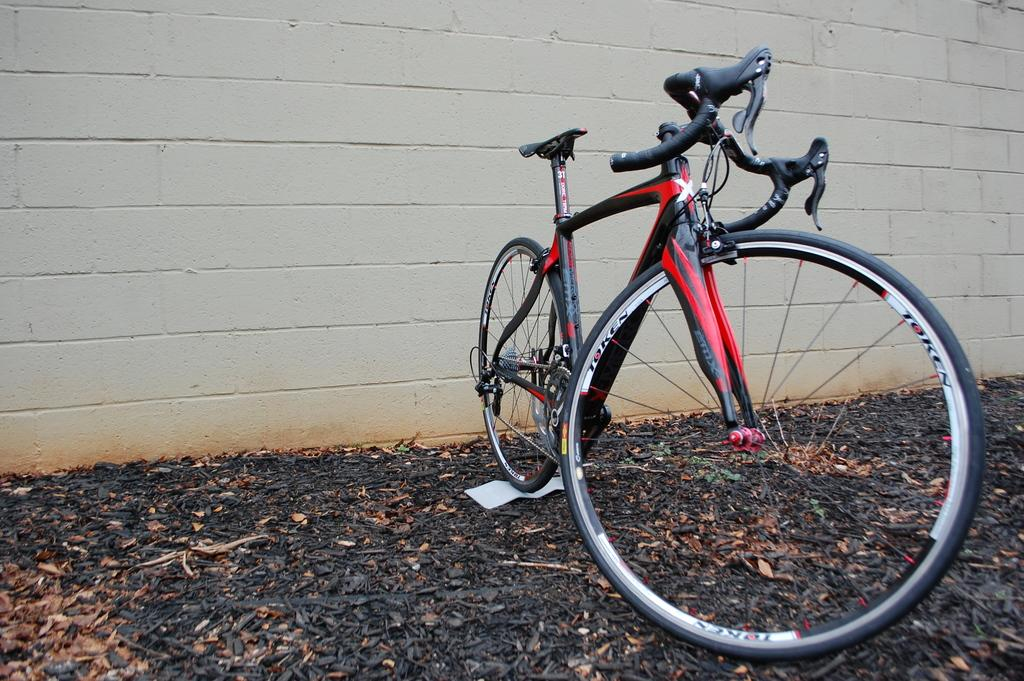What type of vehicle is in the image? There is a red bicycle in the image. How is the bicycle positioned in the image? The bicycle is placed on the ground. What can be seen in the background of the image? There is a wall in the background of the image. What type of smell can be detected in the image? There is no information about smells in the image, so it cannot be determined from the image. 